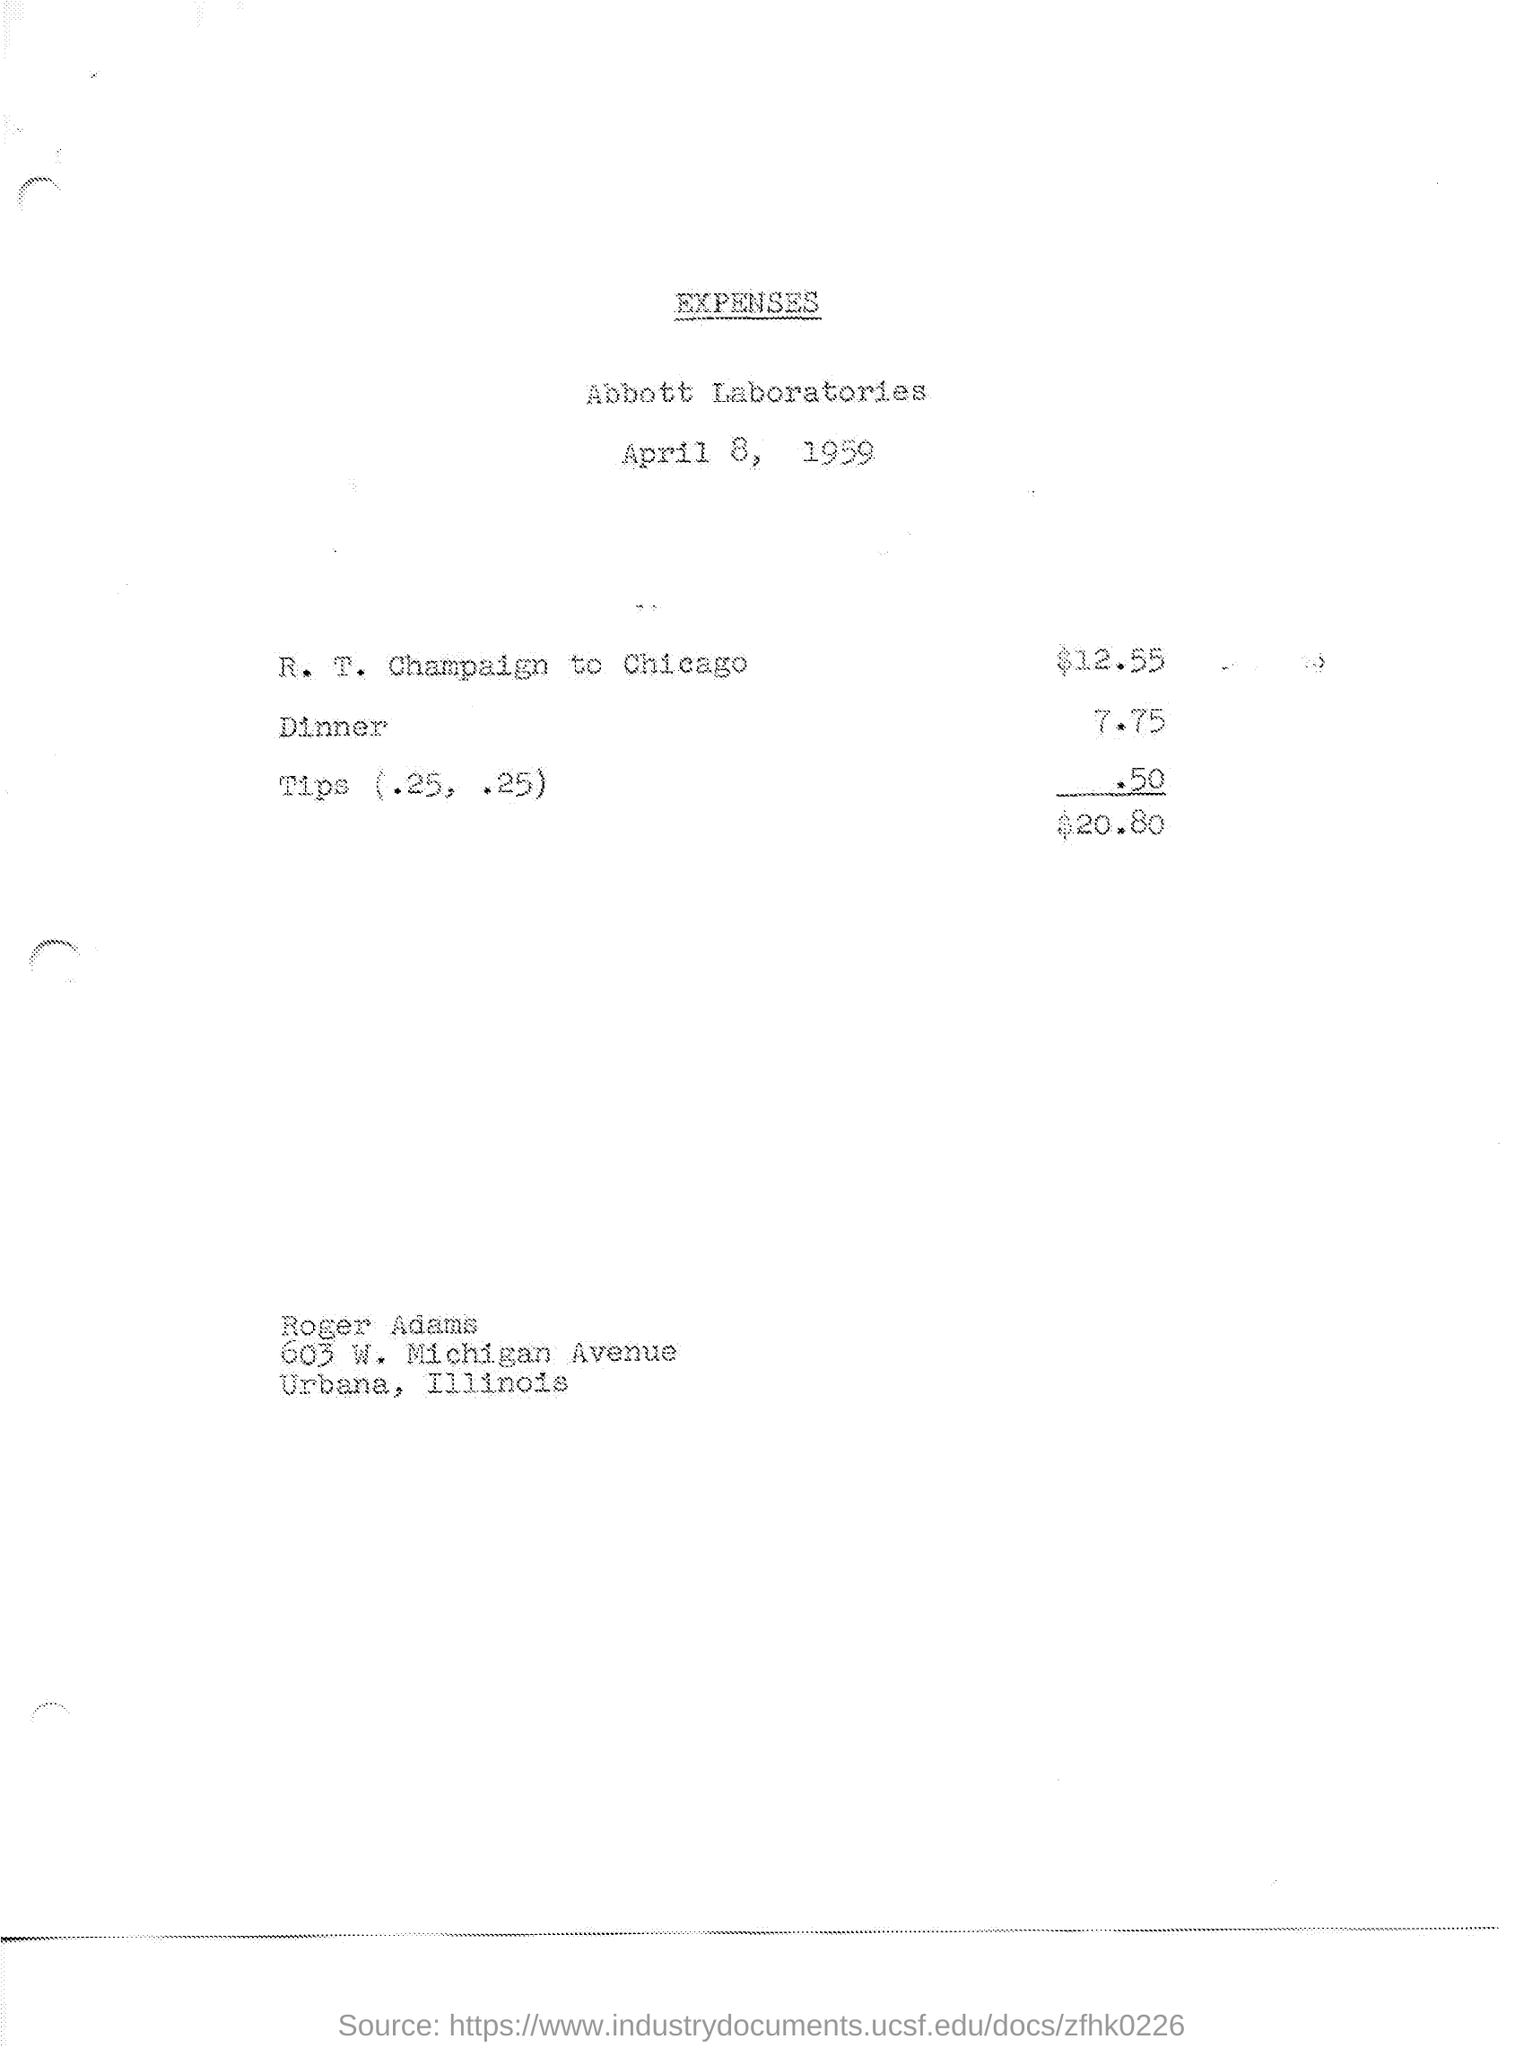What address is listed at the bottom of the expense sheet, and for whom might it be? The address listed at the bottom of the expense sheet is 'Roger Adams, 605 W. Michigan Avenue, Urbana, Illinois'. This could be the address of the individual who submitted the expenses, or where the reimbursement may be sent. 